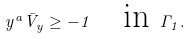Convert formula to latex. <formula><loc_0><loc_0><loc_500><loc_500>y ^ { a } \bar { V } _ { y } \geq - 1 \quad \text {in } \Gamma _ { 1 } .</formula> 